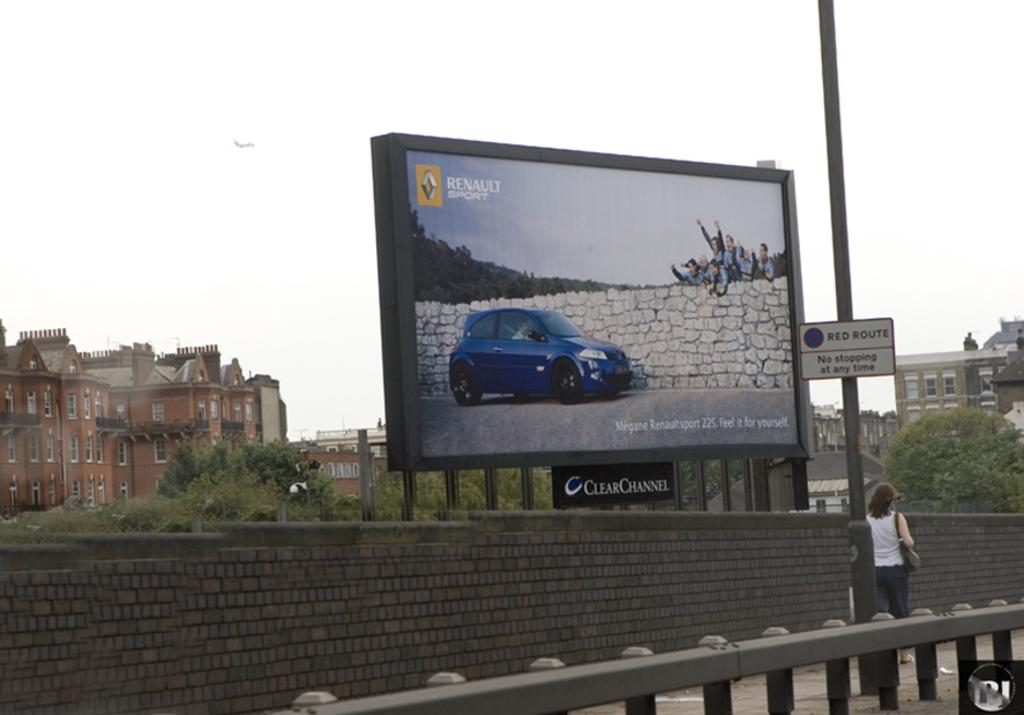What is the woman in the image doing? The woman is walking in the image. What is the woman carrying while walking? The woman is carrying a work bag. What can be seen in the image besides the woman? There is a wall, a board on a pole, a fence, a hoarding, trees, buildings, and the sky visible in the image. What type of whistle can be heard in the image? There is no whistle present in the image, so it is not possible to determine what type of whistle might be heard. 